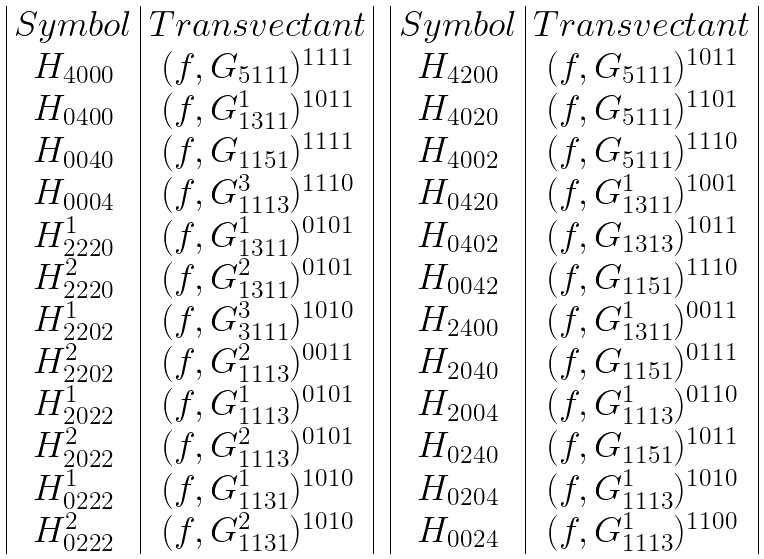Convert formula to latex. <formula><loc_0><loc_0><loc_500><loc_500>\begin{array} { c c } \begin{array} { | c | c | } S y m b o l & T r a n s v e c t a n t \\ H _ { 4 0 0 0 } & ( f , G _ { 5 1 1 1 } ) ^ { 1 1 1 1 } \\ H _ { 0 4 0 0 } & ( f , G _ { 1 3 1 1 } ^ { 1 } ) ^ { 1 0 1 1 } \\ H _ { 0 0 4 0 } & ( f , G _ { 1 1 5 1 } ) ^ { 1 1 1 1 } \\ H _ { 0 0 0 4 } & ( f , G _ { 1 1 1 3 } ^ { 3 } ) ^ { 1 1 1 0 } \\ H _ { 2 2 2 0 } ^ { 1 } & ( f , G _ { 1 3 1 1 } ^ { 1 } ) ^ { 0 1 0 1 } \\ H _ { 2 2 2 0 } ^ { 2 } & ( f , G _ { 1 3 1 1 } ^ { 2 } ) ^ { 0 1 0 1 } \\ H _ { 2 2 0 2 } ^ { 1 } & ( f , G _ { 3 1 1 1 } ^ { 3 } ) ^ { 1 0 1 0 } \\ H _ { 2 2 0 2 } ^ { 2 } & ( f , G _ { 1 1 1 3 } ^ { 2 } ) ^ { 0 0 1 1 } \\ H _ { 2 0 2 2 } ^ { 1 } & ( f , G _ { 1 1 1 3 } ^ { 1 } ) ^ { 0 1 0 1 } \\ H _ { 2 0 2 2 } ^ { 2 } & ( f , G _ { 1 1 1 3 } ^ { 2 } ) ^ { 0 1 0 1 } \\ H _ { 0 2 2 2 } ^ { 1 } & ( f , G _ { 1 1 3 1 } ^ { 1 } ) ^ { 1 0 1 0 } \\ H ^ { 2 } _ { 0 2 2 2 } & ( f , G _ { 1 1 3 1 } ^ { 2 } ) ^ { 1 0 1 0 } \\ \end{array} & \begin{array} { | c | c | } S y m b o l & T r a n s v e c t a n t \\ H _ { 4 2 0 0 } & ( f , G _ { 5 1 1 1 } ) ^ { 1 0 1 1 } \\ H _ { 4 0 2 0 } & ( f , G _ { 5 1 1 1 } ) ^ { 1 1 0 1 } \\ H _ { 4 0 0 2 } & ( f , G _ { 5 1 1 1 } ) ^ { 1 1 1 0 } \\ H _ { 0 4 2 0 } & ( f , G _ { 1 3 1 1 } ^ { 1 } ) ^ { 1 0 0 1 } \\ H _ { 0 4 0 2 } & ( f , G _ { 1 3 1 3 } ) ^ { 1 0 1 1 } \\ H _ { 0 0 4 2 } & ( f , G _ { 1 1 5 1 } ) ^ { 1 1 1 0 } \\ H _ { 2 4 0 0 } & ( f , G _ { 1 3 1 1 } ^ { 1 } ) ^ { 0 0 1 1 } \\ H _ { 2 0 4 0 } & ( f , G _ { 1 1 5 1 } ) ^ { 0 1 1 1 } \\ H _ { 2 0 0 4 } & ( f , G _ { 1 1 1 3 } ^ { 1 } ) ^ { 0 1 1 0 } \\ H _ { 0 2 4 0 } & ( f , G _ { 1 1 5 1 } ) ^ { 1 0 1 1 } \\ H _ { 0 2 0 4 } & ( f , G _ { 1 1 1 3 } ^ { 1 } ) ^ { 1 0 1 0 } \\ H _ { 0 0 2 4 } & ( f , G _ { 1 1 1 3 } ^ { 1 } ) ^ { 1 1 0 0 } \\ \end{array} \end{array}</formula> 